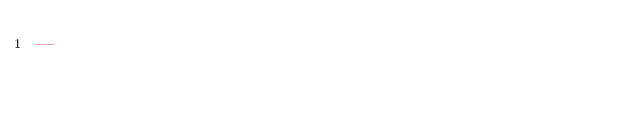Convert code to text. <code><loc_0><loc_0><loc_500><loc_500><_SQL_>--
</code> 